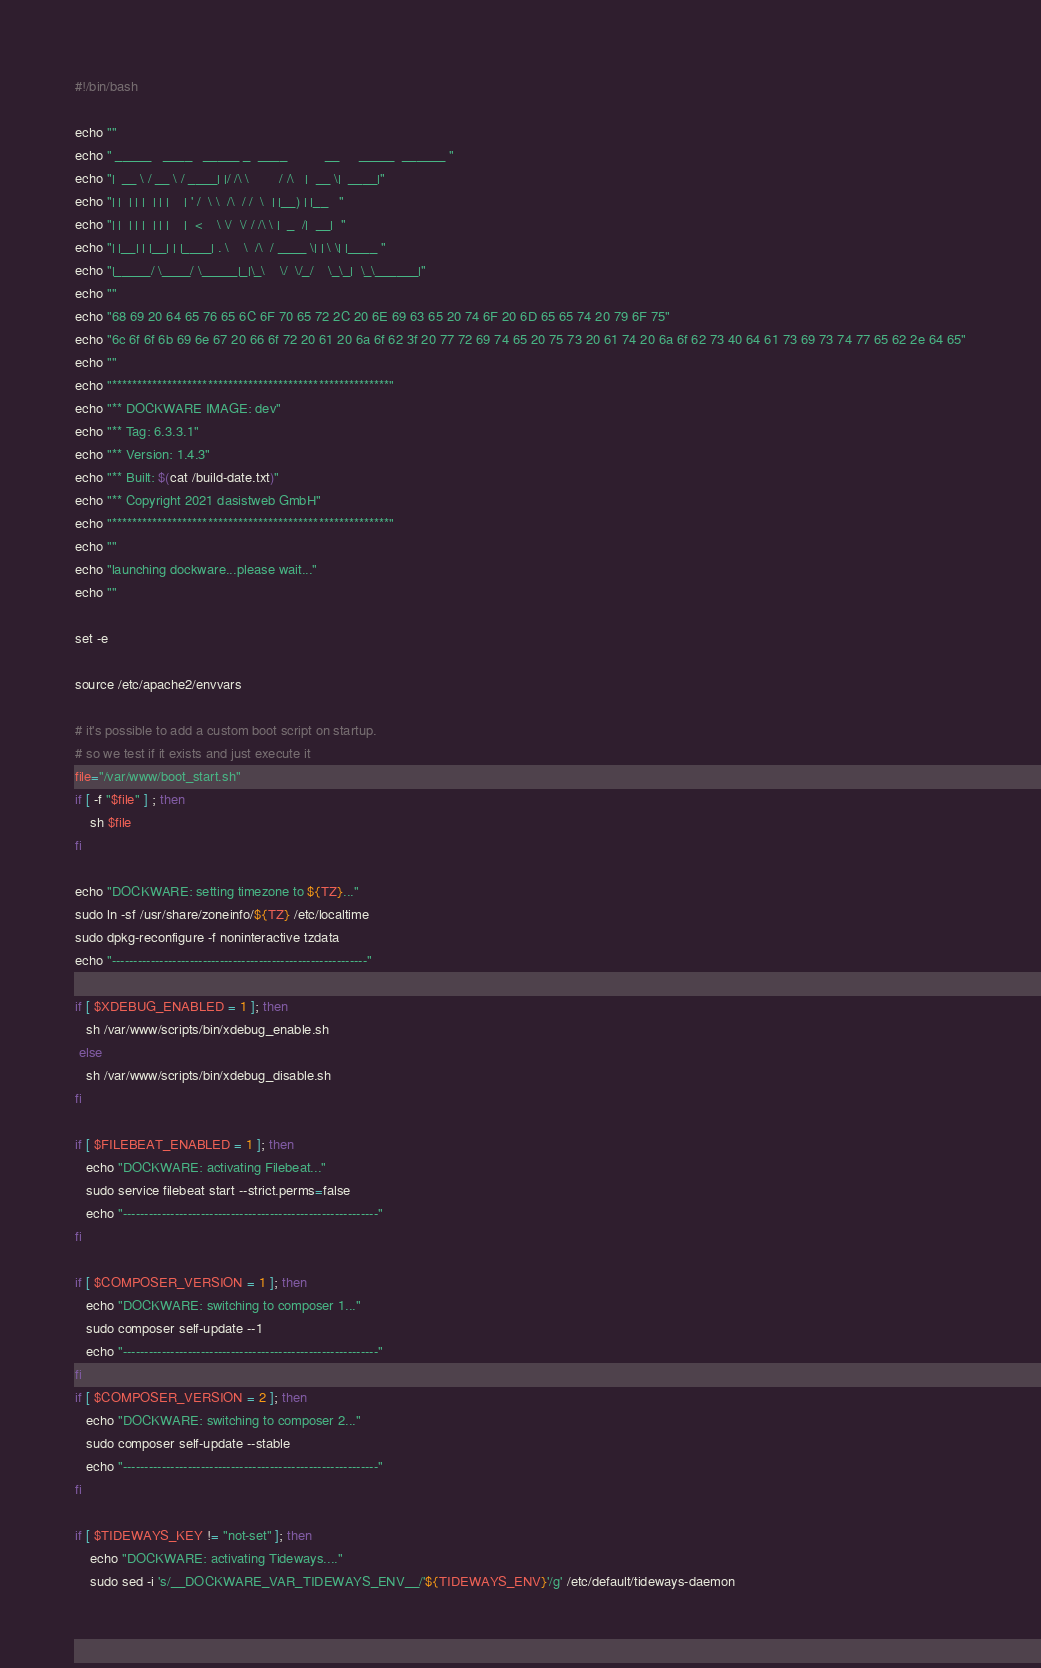<code> <loc_0><loc_0><loc_500><loc_500><_Bash_>#!/bin/bash

echo ""
echo " _____   ____   _____ _  ____          __     _____  ______ "
echo "|  __ \ / __ \ / ____| |/ /\ \        / /\   |  __ \|  ____|"
echo "| |  | | |  | | |    | ' /  \ \  /\  / /  \  | |__) | |__   "
echo "| |  | | |  | | |    |  <    \ \/  \/ / /\ \ |  _  /|  __|  "
echo "| |__| | |__| | |____| . \    \  /\  / ____ \| | \ \| |____ "
echo "|_____/ \____/ \_____|_|\_\    \/  \/_/    \_\_|  \_\______|"
echo ""
echo "68 69 20 64 65 76 65 6C 6F 70 65 72 2C 20 6E 69 63 65 20 74 6F 20 6D 65 65 74 20 79 6F 75"
echo "6c 6f 6f 6b 69 6e 67 20 66 6f 72 20 61 20 6a 6f 62 3f 20 77 72 69 74 65 20 75 73 20 61 74 20 6a 6f 62 73 40 64 61 73 69 73 74 77 65 62 2e 64 65"
echo ""
echo "*******************************************************"
echo "** DOCKWARE IMAGE: dev"
echo "** Tag: 6.3.3.1"
echo "** Version: 1.4.3"
echo "** Built: $(cat /build-date.txt)"
echo "** Copyright 2021 dasistweb GmbH"
echo "*******************************************************"
echo ""
echo "launching dockware...please wait..."
echo ""

set -e

source /etc/apache2/envvars

# it's possible to add a custom boot script on startup.
# so we test if it exists and just execute it
file="/var/www/boot_start.sh"
if [ -f "$file" ] ; then
    sh $file
fi

echo "DOCKWARE: setting timezone to ${TZ}..."
sudo ln -sf /usr/share/zoneinfo/${TZ} /etc/localtime
sudo dpkg-reconfigure -f noninteractive tzdata
echo "-----------------------------------------------------------"

if [ $XDEBUG_ENABLED = 1 ]; then
   sh /var/www/scripts/bin/xdebug_enable.sh
 else
   sh /var/www/scripts/bin/xdebug_disable.sh
fi

if [ $FILEBEAT_ENABLED = 1 ]; then
   echo "DOCKWARE: activating Filebeat..."
   sudo service filebeat start --strict.perms=false
   echo "-----------------------------------------------------------"
fi

if [ $COMPOSER_VERSION = 1 ]; then
   echo "DOCKWARE: switching to composer 1..."
   sudo composer self-update --1
   echo "-----------------------------------------------------------"
fi
if [ $COMPOSER_VERSION = 2 ]; then
   echo "DOCKWARE: switching to composer 2..."
   sudo composer self-update --stable
   echo "-----------------------------------------------------------"
fi

if [ $TIDEWAYS_KEY != "not-set" ]; then
    echo "DOCKWARE: activating Tideways...."
    sudo sed -i 's/__DOCKWARE_VAR_TIDEWAYS_ENV__/'${TIDEWAYS_ENV}'/g' /etc/default/tideways-daemon</code> 